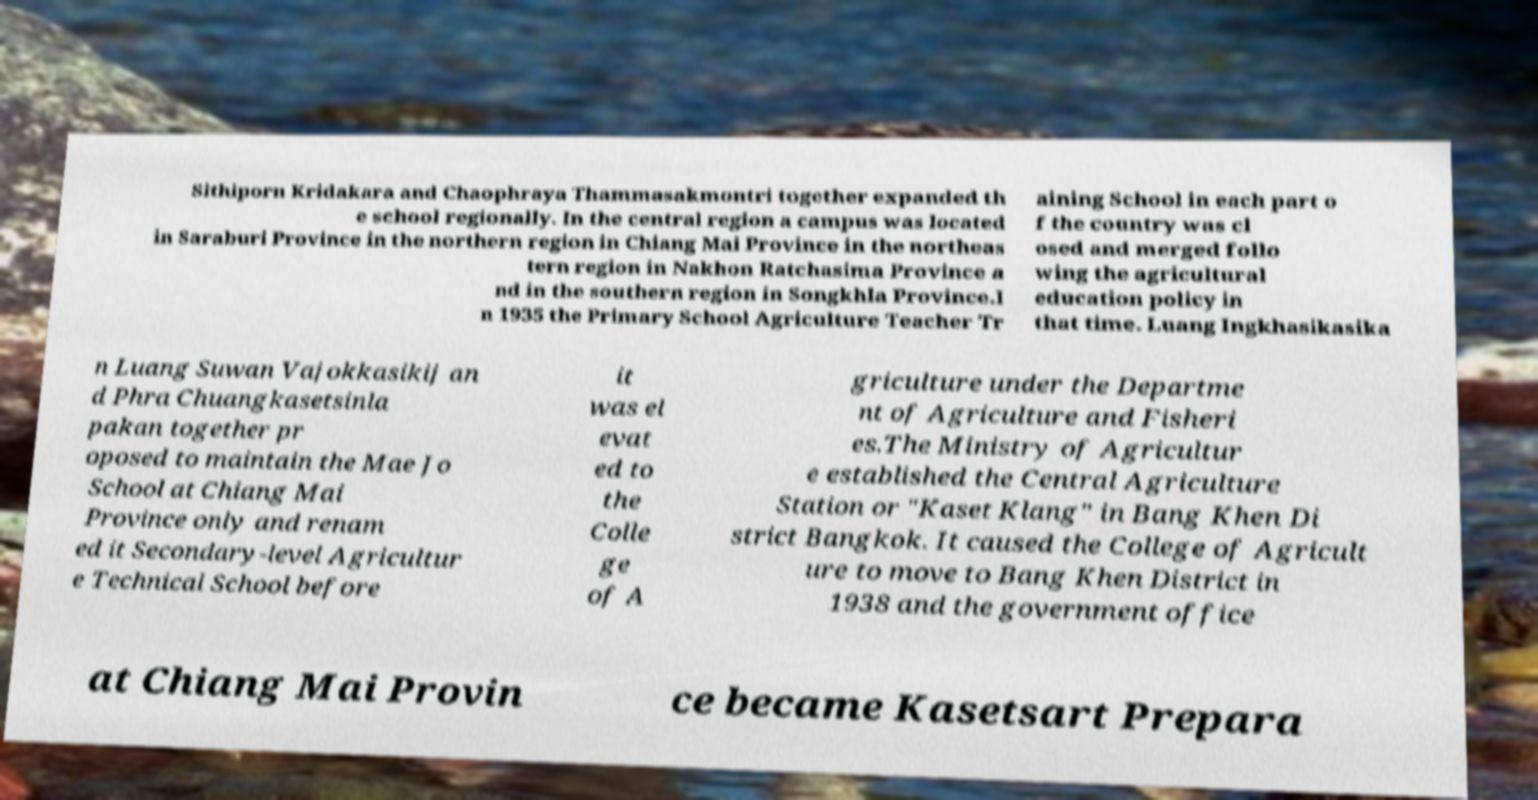What messages or text are displayed in this image? I need them in a readable, typed format. Sithiporn Kridakara and Chaophraya Thammasakmontri together expanded th e school regionally. In the central region a campus was located in Saraburi Province in the northern region in Chiang Mai Province in the northeas tern region in Nakhon Ratchasima Province a nd in the southern region in Songkhla Province.I n 1935 the Primary School Agriculture Teacher Tr aining School in each part o f the country was cl osed and merged follo wing the agricultural education policy in that time. Luang Ingkhasikasika n Luang Suwan Vajokkasikij an d Phra Chuangkasetsinla pakan together pr oposed to maintain the Mae Jo School at Chiang Mai Province only and renam ed it Secondary-level Agricultur e Technical School before it was el evat ed to the Colle ge of A griculture under the Departme nt of Agriculture and Fisheri es.The Ministry of Agricultur e established the Central Agriculture Station or "Kaset Klang" in Bang Khen Di strict Bangkok. It caused the College of Agricult ure to move to Bang Khen District in 1938 and the government office at Chiang Mai Provin ce became Kasetsart Prepara 